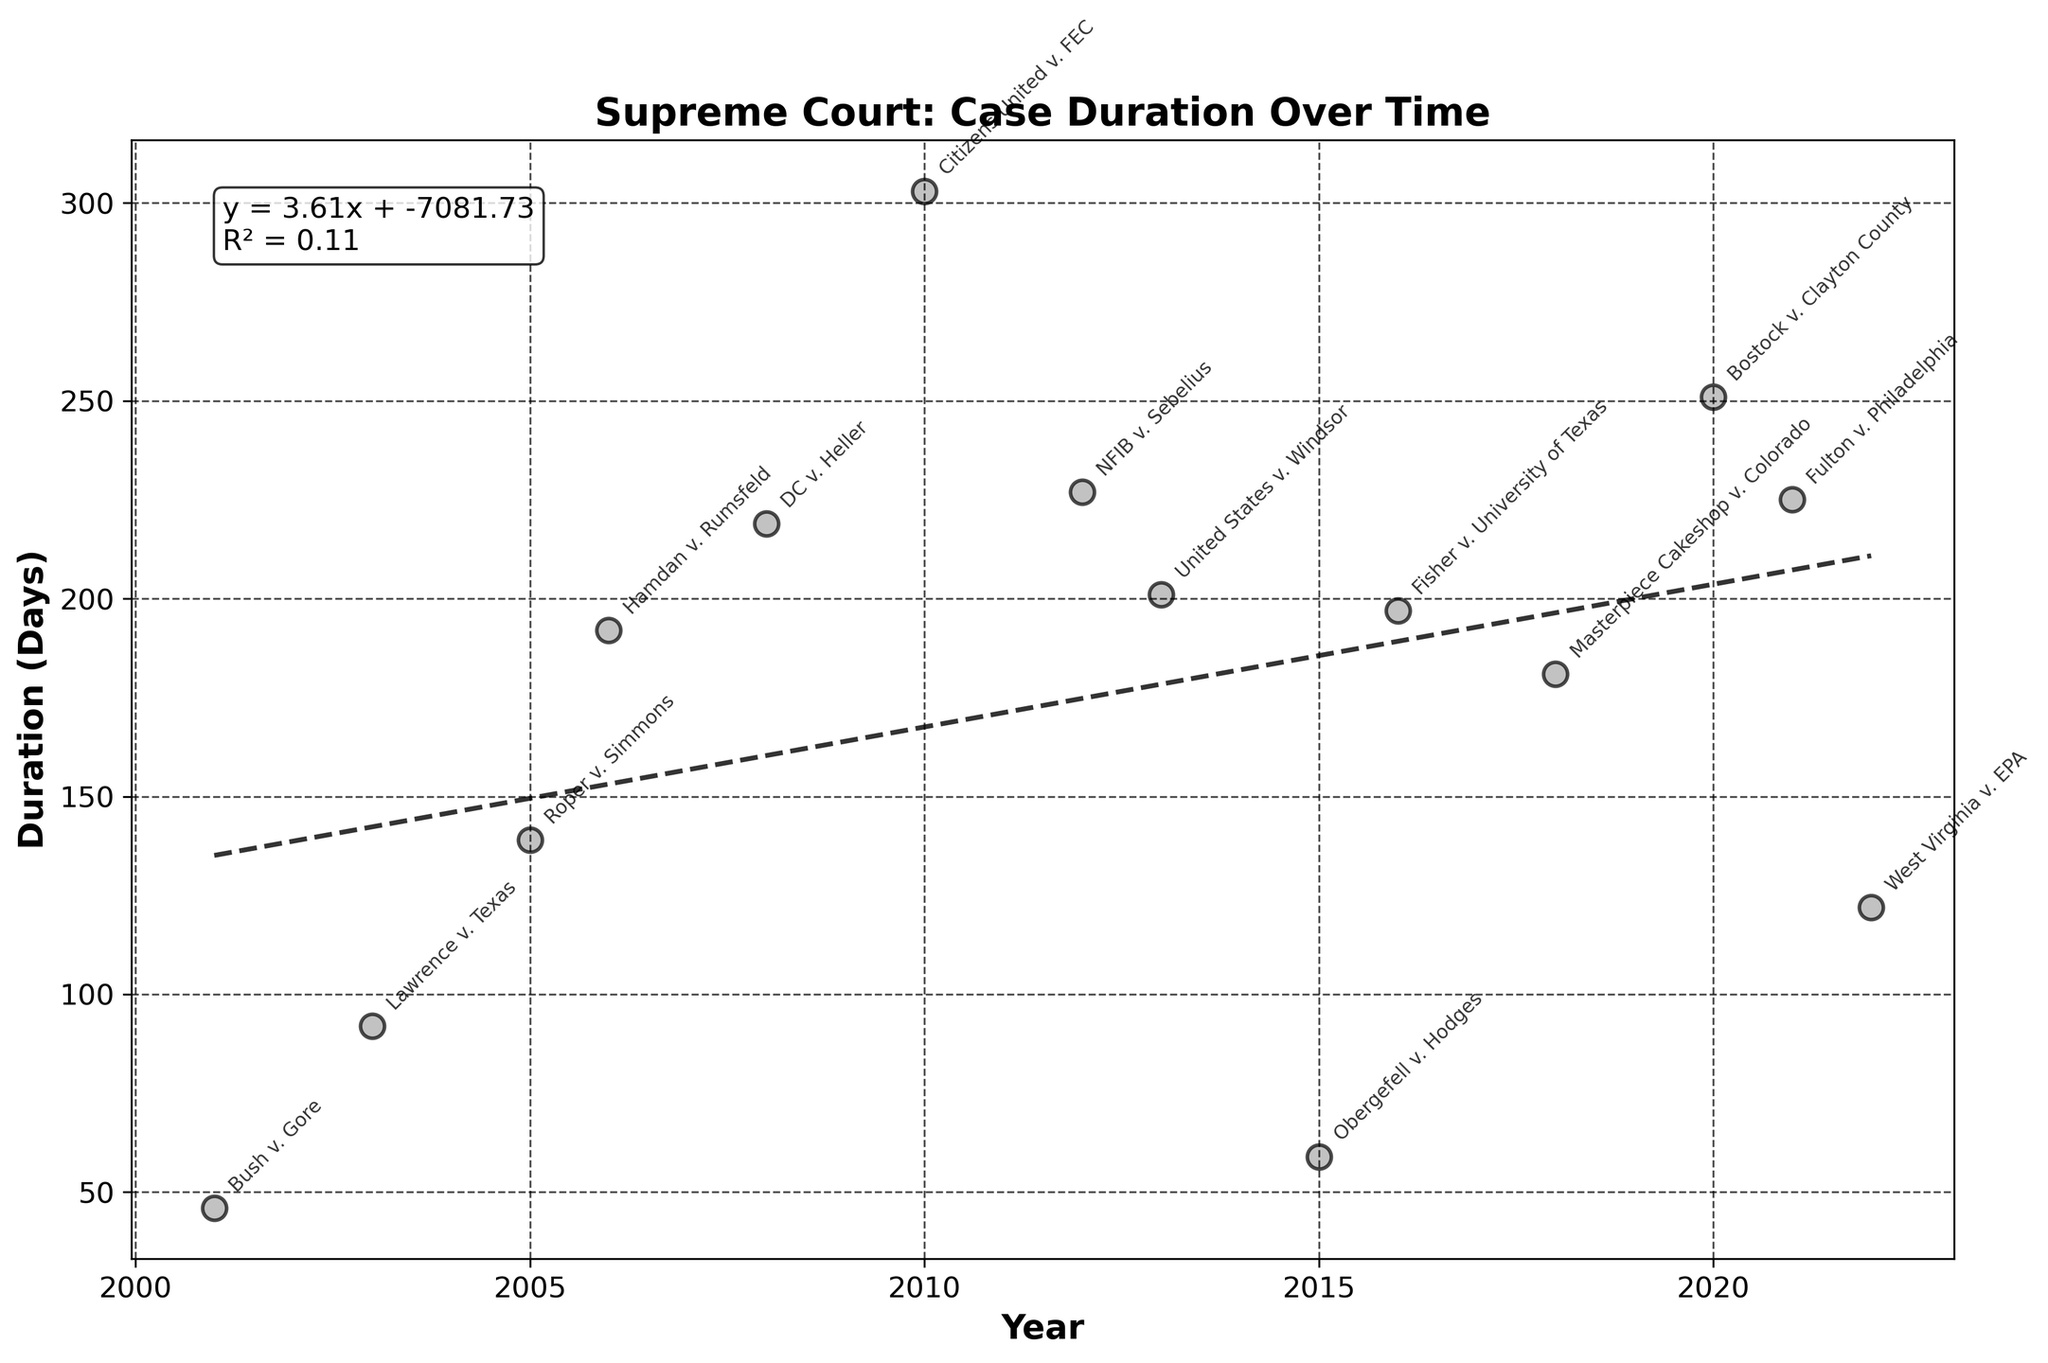What's the title of the scatter plot? The title is usually found at the top of the plot. This plot's title is "Supreme Court: Case Duration Over Time".
Answer: Supreme Court: Case Duration Over Time What's the duration in days for the Bush v. Gore case? Locate the point corresponding to the Bush v. Gore case on the scatter plot and read off the y-axis value, which indicates the duration in days.
Answer: 46 How does the trend line indicate the change in case duration over the years? A trend line shows a general direction of the data points. If the line slopes upward, it indicates an increase in duration over time; if it slopes downward, a decrease.
Answer: Increasing What is the longest duration from case submission to final decision? Identify the highest point on the y-axis which corresponds to the longest duration. The highest y-value is 303 days, which corresponds to Citizens United v. FEC case in 2010.
Answer: 303 days What is the R-squared value of the trend line? The R-squared value is displayed in the equation at the top right of the plot. It indicates the goodness-of-fit of the trend line.
Answer: 0.48 Compare the durations for the cases Fisher v. University of Texas and Bostock v. Clayton County. Which case took longer? Locate both points for the given cases on the scatter plot and compare their y-values (durations). Bostock v. Clayton County (251 days) took longer than Fisher v. University of Texas (198 days).
Answer: Bostock v. Clayton County What's the shortest duration from case submission to final decision? Identify the lowest point on the y-axis which corresponds to the shortest duration. The lowest y-value is 46 days for the Bush v. Gore case in 2001.
Answer: 46 days What is the average duration of all Supreme Court cases included in the plot? Add all the durations from each case and divide by the number of cases. The total duration = 46 + 92 + 140 + 192 + 219 + 303 + 228 + 201 + 59 + 198 + 181 + 251 + 225 + 122 = 2457 days. Then, divide by 14 cases: 2457 / 14 ≈ 175.5 days.
Answer: 175.5 days Which case has the closest duration to the trend line in 2018? Find the data point for the year 2018 and compare its y-value to the y-value of the trend line for that year. Masterpiece Cakeshop v. Colorado, 2018 (181 days) is the closest case.
Answer: Masterpiece Cakeshop v. Colorado 